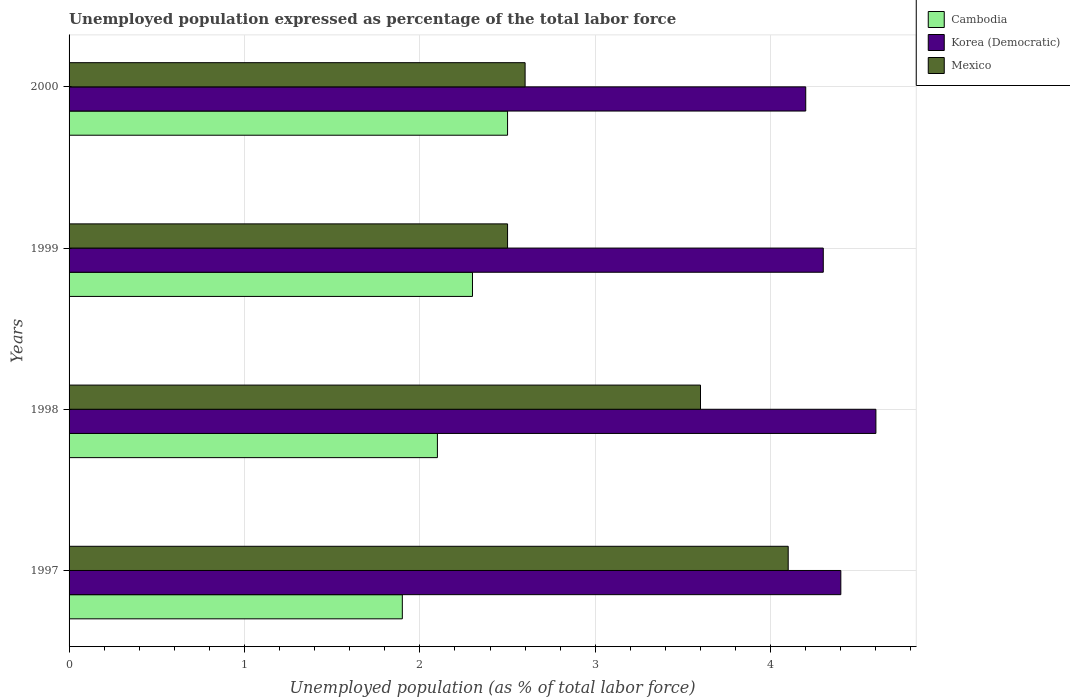How many groups of bars are there?
Provide a succinct answer. 4. What is the label of the 3rd group of bars from the top?
Your response must be concise. 1998. In how many cases, is the number of bars for a given year not equal to the number of legend labels?
Ensure brevity in your answer.  0. Across all years, what is the maximum unemployment in in Korea (Democratic)?
Your response must be concise. 4.6. Across all years, what is the minimum unemployment in in Korea (Democratic)?
Your response must be concise. 4.2. In which year was the unemployment in in Mexico minimum?
Provide a short and direct response. 1999. What is the total unemployment in in Korea (Democratic) in the graph?
Offer a terse response. 17.5. What is the difference between the unemployment in in Korea (Democratic) in 1998 and that in 1999?
Your response must be concise. 0.3. What is the difference between the unemployment in in Cambodia in 2000 and the unemployment in in Mexico in 1997?
Your answer should be compact. -1.6. What is the average unemployment in in Korea (Democratic) per year?
Ensure brevity in your answer.  4.38. What is the ratio of the unemployment in in Cambodia in 1999 to that in 2000?
Your answer should be compact. 0.92. Is the unemployment in in Cambodia in 1999 less than that in 2000?
Make the answer very short. Yes. Is the difference between the unemployment in in Mexico in 1998 and 1999 greater than the difference between the unemployment in in Cambodia in 1998 and 1999?
Your response must be concise. Yes. What is the difference between the highest and the second highest unemployment in in Korea (Democratic)?
Provide a succinct answer. 0.2. What is the difference between the highest and the lowest unemployment in in Cambodia?
Provide a succinct answer. 0.6. What does the 2nd bar from the top in 2000 represents?
Ensure brevity in your answer.  Korea (Democratic). What does the 3rd bar from the bottom in 1999 represents?
Your answer should be very brief. Mexico. How many bars are there?
Offer a very short reply. 12. How many years are there in the graph?
Give a very brief answer. 4. Where does the legend appear in the graph?
Provide a succinct answer. Top right. How many legend labels are there?
Make the answer very short. 3. What is the title of the graph?
Provide a succinct answer. Unemployed population expressed as percentage of the total labor force. Does "Canada" appear as one of the legend labels in the graph?
Ensure brevity in your answer.  No. What is the label or title of the X-axis?
Offer a terse response. Unemployed population (as % of total labor force). What is the label or title of the Y-axis?
Your answer should be compact. Years. What is the Unemployed population (as % of total labor force) in Cambodia in 1997?
Offer a terse response. 1.9. What is the Unemployed population (as % of total labor force) in Korea (Democratic) in 1997?
Your answer should be compact. 4.4. What is the Unemployed population (as % of total labor force) in Mexico in 1997?
Offer a very short reply. 4.1. What is the Unemployed population (as % of total labor force) of Cambodia in 1998?
Your answer should be very brief. 2.1. What is the Unemployed population (as % of total labor force) of Korea (Democratic) in 1998?
Provide a short and direct response. 4.6. What is the Unemployed population (as % of total labor force) in Mexico in 1998?
Your answer should be compact. 3.6. What is the Unemployed population (as % of total labor force) in Cambodia in 1999?
Provide a succinct answer. 2.3. What is the Unemployed population (as % of total labor force) of Korea (Democratic) in 1999?
Provide a succinct answer. 4.3. What is the Unemployed population (as % of total labor force) in Mexico in 1999?
Give a very brief answer. 2.5. What is the Unemployed population (as % of total labor force) in Korea (Democratic) in 2000?
Provide a short and direct response. 4.2. What is the Unemployed population (as % of total labor force) in Mexico in 2000?
Give a very brief answer. 2.6. Across all years, what is the maximum Unemployed population (as % of total labor force) of Cambodia?
Your answer should be compact. 2.5. Across all years, what is the maximum Unemployed population (as % of total labor force) in Korea (Democratic)?
Your response must be concise. 4.6. Across all years, what is the maximum Unemployed population (as % of total labor force) of Mexico?
Provide a succinct answer. 4.1. Across all years, what is the minimum Unemployed population (as % of total labor force) in Cambodia?
Your answer should be very brief. 1.9. Across all years, what is the minimum Unemployed population (as % of total labor force) of Korea (Democratic)?
Provide a succinct answer. 4.2. What is the total Unemployed population (as % of total labor force) in Korea (Democratic) in the graph?
Provide a short and direct response. 17.5. What is the difference between the Unemployed population (as % of total labor force) in Cambodia in 1997 and that in 1998?
Provide a succinct answer. -0.2. What is the difference between the Unemployed population (as % of total labor force) of Korea (Democratic) in 1997 and that in 1998?
Your answer should be compact. -0.2. What is the difference between the Unemployed population (as % of total labor force) of Cambodia in 1997 and that in 1999?
Give a very brief answer. -0.4. What is the difference between the Unemployed population (as % of total labor force) in Korea (Democratic) in 1997 and that in 1999?
Your answer should be compact. 0.1. What is the difference between the Unemployed population (as % of total labor force) in Mexico in 1997 and that in 1999?
Your answer should be compact. 1.6. What is the difference between the Unemployed population (as % of total labor force) in Cambodia in 1997 and that in 2000?
Provide a short and direct response. -0.6. What is the difference between the Unemployed population (as % of total labor force) in Mexico in 1998 and that in 1999?
Offer a terse response. 1.1. What is the difference between the Unemployed population (as % of total labor force) of Cambodia in 1998 and that in 2000?
Your answer should be very brief. -0.4. What is the difference between the Unemployed population (as % of total labor force) of Mexico in 1998 and that in 2000?
Ensure brevity in your answer.  1. What is the difference between the Unemployed population (as % of total labor force) in Korea (Democratic) in 1999 and that in 2000?
Give a very brief answer. 0.1. What is the difference between the Unemployed population (as % of total labor force) of Mexico in 1999 and that in 2000?
Offer a very short reply. -0.1. What is the difference between the Unemployed population (as % of total labor force) of Cambodia in 1997 and the Unemployed population (as % of total labor force) of Mexico in 1998?
Provide a succinct answer. -1.7. What is the difference between the Unemployed population (as % of total labor force) in Korea (Democratic) in 1997 and the Unemployed population (as % of total labor force) in Mexico in 1999?
Your answer should be compact. 1.9. What is the difference between the Unemployed population (as % of total labor force) of Cambodia in 1997 and the Unemployed population (as % of total labor force) of Korea (Democratic) in 2000?
Give a very brief answer. -2.3. What is the difference between the Unemployed population (as % of total labor force) of Korea (Democratic) in 1997 and the Unemployed population (as % of total labor force) of Mexico in 2000?
Offer a very short reply. 1.8. What is the difference between the Unemployed population (as % of total labor force) of Cambodia in 1998 and the Unemployed population (as % of total labor force) of Mexico in 1999?
Give a very brief answer. -0.4. What is the difference between the Unemployed population (as % of total labor force) of Korea (Democratic) in 1998 and the Unemployed population (as % of total labor force) of Mexico in 1999?
Your answer should be very brief. 2.1. What is the difference between the Unemployed population (as % of total labor force) in Cambodia in 1998 and the Unemployed population (as % of total labor force) in Mexico in 2000?
Ensure brevity in your answer.  -0.5. What is the difference between the Unemployed population (as % of total labor force) in Cambodia in 1999 and the Unemployed population (as % of total labor force) in Korea (Democratic) in 2000?
Provide a short and direct response. -1.9. What is the difference between the Unemployed population (as % of total labor force) in Cambodia in 1999 and the Unemployed population (as % of total labor force) in Mexico in 2000?
Make the answer very short. -0.3. What is the average Unemployed population (as % of total labor force) of Cambodia per year?
Offer a very short reply. 2.2. What is the average Unemployed population (as % of total labor force) of Korea (Democratic) per year?
Offer a terse response. 4.38. In the year 1997, what is the difference between the Unemployed population (as % of total labor force) of Cambodia and Unemployed population (as % of total labor force) of Korea (Democratic)?
Offer a very short reply. -2.5. In the year 1997, what is the difference between the Unemployed population (as % of total labor force) in Cambodia and Unemployed population (as % of total labor force) in Mexico?
Offer a very short reply. -2.2. In the year 1997, what is the difference between the Unemployed population (as % of total labor force) in Korea (Democratic) and Unemployed population (as % of total labor force) in Mexico?
Provide a short and direct response. 0.3. In the year 1998, what is the difference between the Unemployed population (as % of total labor force) in Cambodia and Unemployed population (as % of total labor force) in Mexico?
Offer a terse response. -1.5. In the year 2000, what is the difference between the Unemployed population (as % of total labor force) of Cambodia and Unemployed population (as % of total labor force) of Korea (Democratic)?
Provide a short and direct response. -1.7. In the year 2000, what is the difference between the Unemployed population (as % of total labor force) of Cambodia and Unemployed population (as % of total labor force) of Mexico?
Offer a very short reply. -0.1. In the year 2000, what is the difference between the Unemployed population (as % of total labor force) of Korea (Democratic) and Unemployed population (as % of total labor force) of Mexico?
Give a very brief answer. 1.6. What is the ratio of the Unemployed population (as % of total labor force) in Cambodia in 1997 to that in 1998?
Offer a terse response. 0.9. What is the ratio of the Unemployed population (as % of total labor force) of Korea (Democratic) in 1997 to that in 1998?
Your response must be concise. 0.96. What is the ratio of the Unemployed population (as % of total labor force) in Mexico in 1997 to that in 1998?
Make the answer very short. 1.14. What is the ratio of the Unemployed population (as % of total labor force) in Cambodia in 1997 to that in 1999?
Offer a very short reply. 0.83. What is the ratio of the Unemployed population (as % of total labor force) of Korea (Democratic) in 1997 to that in 1999?
Your answer should be compact. 1.02. What is the ratio of the Unemployed population (as % of total labor force) in Mexico in 1997 to that in 1999?
Your answer should be very brief. 1.64. What is the ratio of the Unemployed population (as % of total labor force) in Cambodia in 1997 to that in 2000?
Offer a terse response. 0.76. What is the ratio of the Unemployed population (as % of total labor force) of Korea (Democratic) in 1997 to that in 2000?
Offer a terse response. 1.05. What is the ratio of the Unemployed population (as % of total labor force) of Mexico in 1997 to that in 2000?
Provide a short and direct response. 1.58. What is the ratio of the Unemployed population (as % of total labor force) in Cambodia in 1998 to that in 1999?
Provide a short and direct response. 0.91. What is the ratio of the Unemployed population (as % of total labor force) in Korea (Democratic) in 1998 to that in 1999?
Give a very brief answer. 1.07. What is the ratio of the Unemployed population (as % of total labor force) in Mexico in 1998 to that in 1999?
Offer a very short reply. 1.44. What is the ratio of the Unemployed population (as % of total labor force) in Cambodia in 1998 to that in 2000?
Your answer should be compact. 0.84. What is the ratio of the Unemployed population (as % of total labor force) of Korea (Democratic) in 1998 to that in 2000?
Your response must be concise. 1.1. What is the ratio of the Unemployed population (as % of total labor force) of Mexico in 1998 to that in 2000?
Your answer should be compact. 1.38. What is the ratio of the Unemployed population (as % of total labor force) in Korea (Democratic) in 1999 to that in 2000?
Give a very brief answer. 1.02. What is the ratio of the Unemployed population (as % of total labor force) of Mexico in 1999 to that in 2000?
Your answer should be compact. 0.96. What is the difference between the highest and the second highest Unemployed population (as % of total labor force) in Cambodia?
Provide a short and direct response. 0.2. What is the difference between the highest and the second highest Unemployed population (as % of total labor force) of Korea (Democratic)?
Offer a terse response. 0.2. What is the difference between the highest and the second highest Unemployed population (as % of total labor force) of Mexico?
Make the answer very short. 0.5. What is the difference between the highest and the lowest Unemployed population (as % of total labor force) in Cambodia?
Give a very brief answer. 0.6. What is the difference between the highest and the lowest Unemployed population (as % of total labor force) of Korea (Democratic)?
Your answer should be very brief. 0.4. 